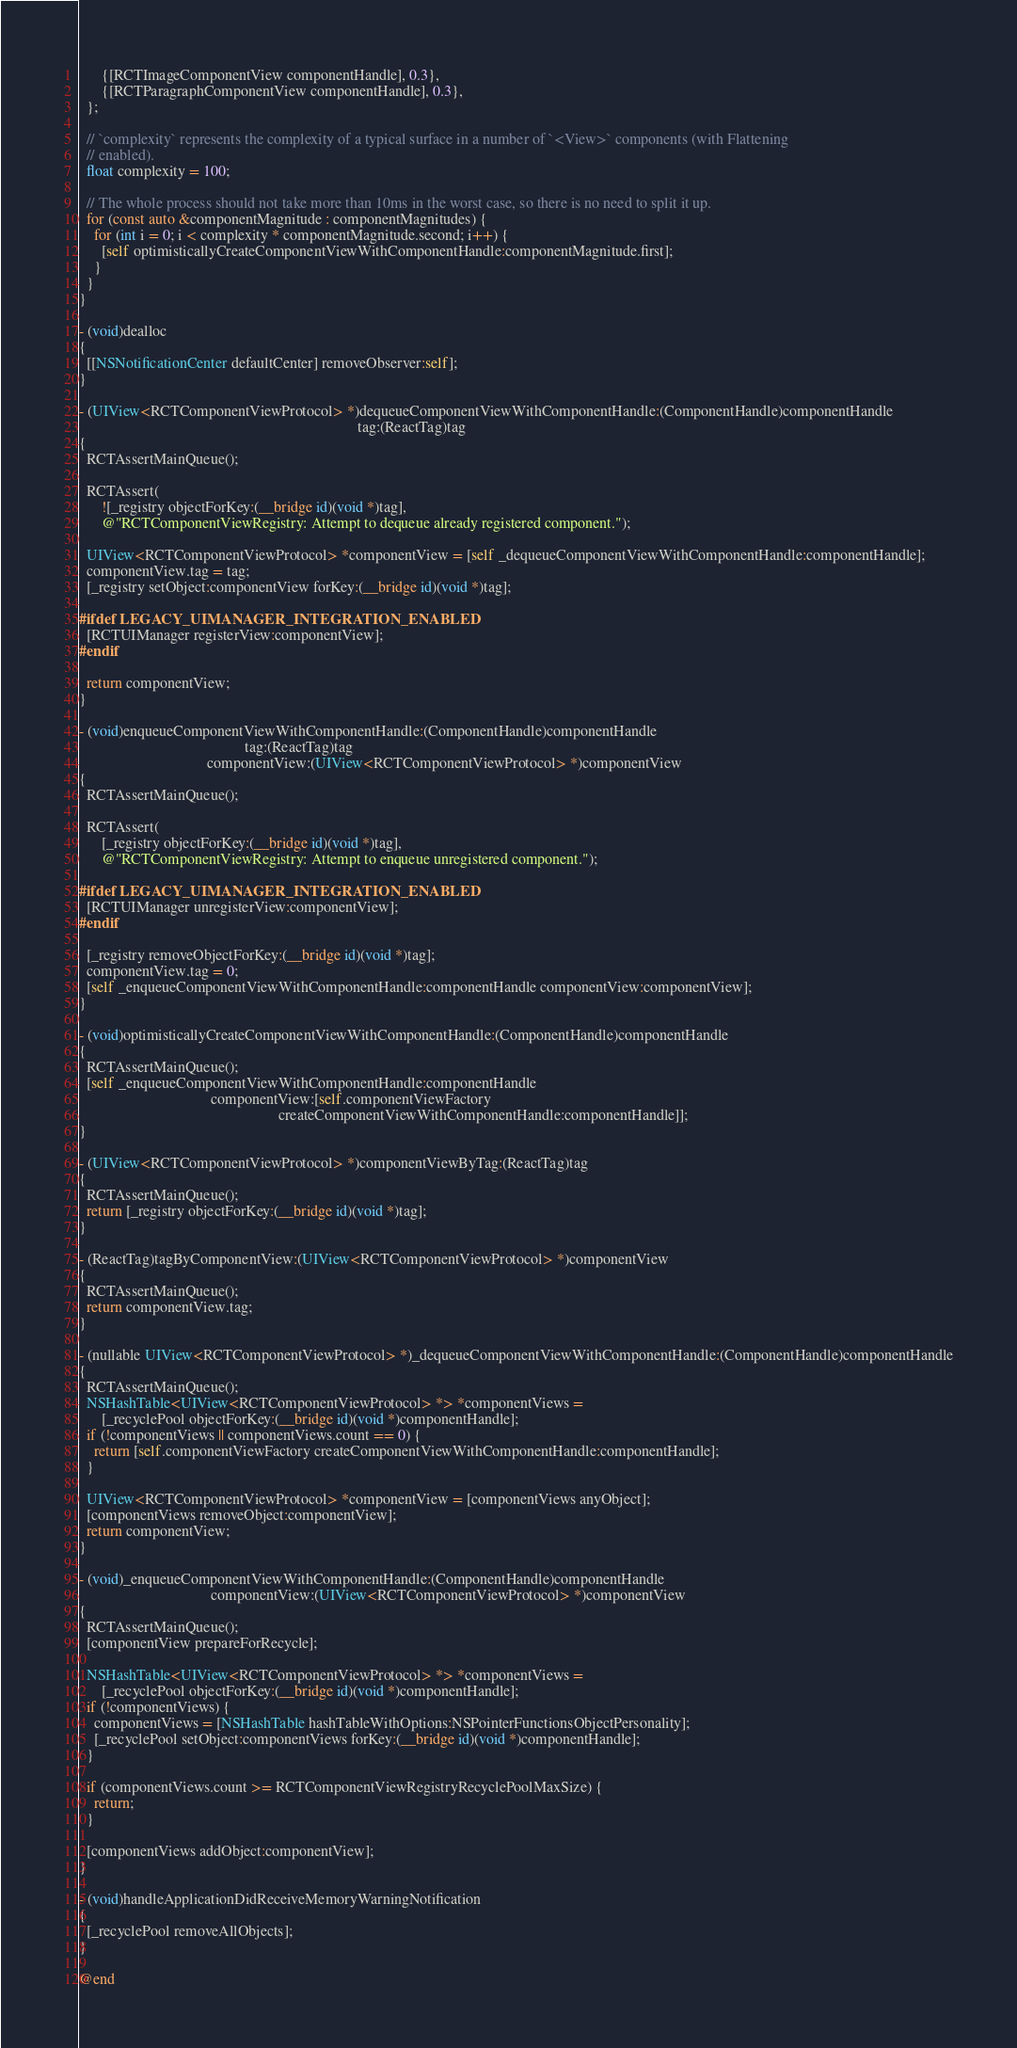<code> <loc_0><loc_0><loc_500><loc_500><_ObjectiveC_>      {[RCTImageComponentView componentHandle], 0.3},
      {[RCTParagraphComponentView componentHandle], 0.3},
  };

  // `complexity` represents the complexity of a typical surface in a number of `<View>` components (with Flattening
  // enabled).
  float complexity = 100;

  // The whole process should not take more than 10ms in the worst case, so there is no need to split it up.
  for (const auto &componentMagnitude : componentMagnitudes) {
    for (int i = 0; i < complexity * componentMagnitude.second; i++) {
      [self optimisticallyCreateComponentViewWithComponentHandle:componentMagnitude.first];
    }
  }
}

- (void)dealloc
{
  [[NSNotificationCenter defaultCenter] removeObserver:self];
}

- (UIView<RCTComponentViewProtocol> *)dequeueComponentViewWithComponentHandle:(ComponentHandle)componentHandle
                                                                          tag:(ReactTag)tag
{
  RCTAssertMainQueue();

  RCTAssert(
      ![_registry objectForKey:(__bridge id)(void *)tag],
      @"RCTComponentViewRegistry: Attempt to dequeue already registered component.");

  UIView<RCTComponentViewProtocol> *componentView = [self _dequeueComponentViewWithComponentHandle:componentHandle];
  componentView.tag = tag;
  [_registry setObject:componentView forKey:(__bridge id)(void *)tag];

#ifdef LEGACY_UIMANAGER_INTEGRATION_ENABLED
  [RCTUIManager registerView:componentView];
#endif

  return componentView;
}

- (void)enqueueComponentViewWithComponentHandle:(ComponentHandle)componentHandle
                                            tag:(ReactTag)tag
                                  componentView:(UIView<RCTComponentViewProtocol> *)componentView
{
  RCTAssertMainQueue();

  RCTAssert(
      [_registry objectForKey:(__bridge id)(void *)tag],
      @"RCTComponentViewRegistry: Attempt to enqueue unregistered component.");

#ifdef LEGACY_UIMANAGER_INTEGRATION_ENABLED
  [RCTUIManager unregisterView:componentView];
#endif

  [_registry removeObjectForKey:(__bridge id)(void *)tag];
  componentView.tag = 0;
  [self _enqueueComponentViewWithComponentHandle:componentHandle componentView:componentView];
}

- (void)optimisticallyCreateComponentViewWithComponentHandle:(ComponentHandle)componentHandle
{
  RCTAssertMainQueue();
  [self _enqueueComponentViewWithComponentHandle:componentHandle
                                   componentView:[self.componentViewFactory
                                                     createComponentViewWithComponentHandle:componentHandle]];
}

- (UIView<RCTComponentViewProtocol> *)componentViewByTag:(ReactTag)tag
{
  RCTAssertMainQueue();
  return [_registry objectForKey:(__bridge id)(void *)tag];
}

- (ReactTag)tagByComponentView:(UIView<RCTComponentViewProtocol> *)componentView
{
  RCTAssertMainQueue();
  return componentView.tag;
}

- (nullable UIView<RCTComponentViewProtocol> *)_dequeueComponentViewWithComponentHandle:(ComponentHandle)componentHandle
{
  RCTAssertMainQueue();
  NSHashTable<UIView<RCTComponentViewProtocol> *> *componentViews =
      [_recyclePool objectForKey:(__bridge id)(void *)componentHandle];
  if (!componentViews || componentViews.count == 0) {
    return [self.componentViewFactory createComponentViewWithComponentHandle:componentHandle];
  }

  UIView<RCTComponentViewProtocol> *componentView = [componentViews anyObject];
  [componentViews removeObject:componentView];
  return componentView;
}

- (void)_enqueueComponentViewWithComponentHandle:(ComponentHandle)componentHandle
                                   componentView:(UIView<RCTComponentViewProtocol> *)componentView
{
  RCTAssertMainQueue();
  [componentView prepareForRecycle];

  NSHashTable<UIView<RCTComponentViewProtocol> *> *componentViews =
      [_recyclePool objectForKey:(__bridge id)(void *)componentHandle];
  if (!componentViews) {
    componentViews = [NSHashTable hashTableWithOptions:NSPointerFunctionsObjectPersonality];
    [_recyclePool setObject:componentViews forKey:(__bridge id)(void *)componentHandle];
  }

  if (componentViews.count >= RCTComponentViewRegistryRecyclePoolMaxSize) {
    return;
  }

  [componentViews addObject:componentView];
}

- (void)handleApplicationDidReceiveMemoryWarningNotification
{
  [_recyclePool removeAllObjects];
}

@end
</code> 